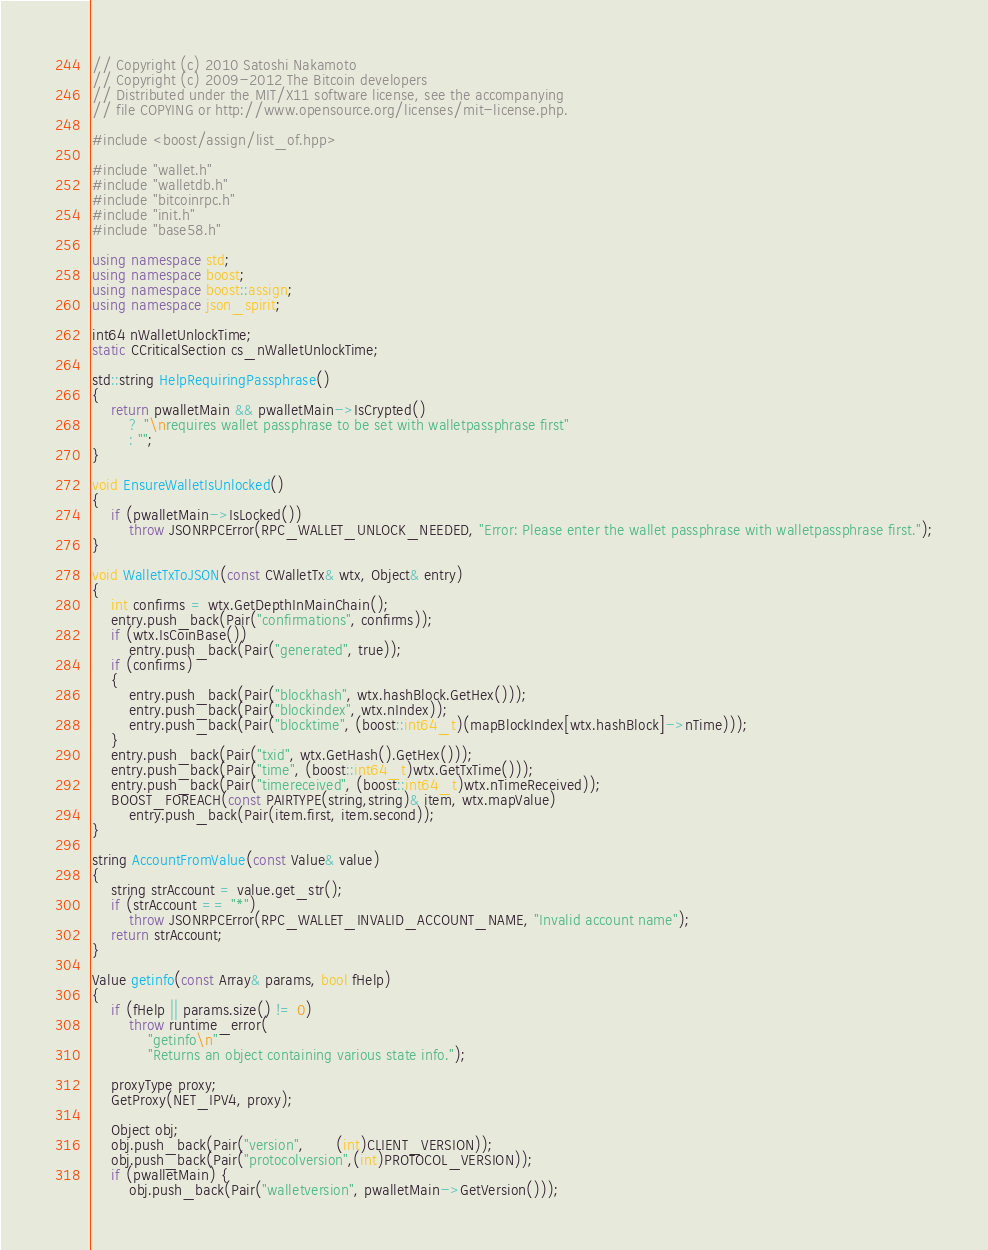Convert code to text. <code><loc_0><loc_0><loc_500><loc_500><_C++_>// Copyright (c) 2010 Satoshi Nakamoto
// Copyright (c) 2009-2012 The Bitcoin developers
// Distributed under the MIT/X11 software license, see the accompanying
// file COPYING or http://www.opensource.org/licenses/mit-license.php.

#include <boost/assign/list_of.hpp>

#include "wallet.h"
#include "walletdb.h"
#include "bitcoinrpc.h"
#include "init.h"
#include "base58.h"

using namespace std;
using namespace boost;
using namespace boost::assign;
using namespace json_spirit;

int64 nWalletUnlockTime;
static CCriticalSection cs_nWalletUnlockTime;

std::string HelpRequiringPassphrase()
{
    return pwalletMain && pwalletMain->IsCrypted()
        ? "\nrequires wallet passphrase to be set with walletpassphrase first"
        : "";
}

void EnsureWalletIsUnlocked()
{
    if (pwalletMain->IsLocked())
        throw JSONRPCError(RPC_WALLET_UNLOCK_NEEDED, "Error: Please enter the wallet passphrase with walletpassphrase first.");
}

void WalletTxToJSON(const CWalletTx& wtx, Object& entry)
{
    int confirms = wtx.GetDepthInMainChain();
    entry.push_back(Pair("confirmations", confirms));
    if (wtx.IsCoinBase())
        entry.push_back(Pair("generated", true));
    if (confirms)
    {
        entry.push_back(Pair("blockhash", wtx.hashBlock.GetHex()));
        entry.push_back(Pair("blockindex", wtx.nIndex));
        entry.push_back(Pair("blocktime", (boost::int64_t)(mapBlockIndex[wtx.hashBlock]->nTime)));
    }
    entry.push_back(Pair("txid", wtx.GetHash().GetHex()));
    entry.push_back(Pair("time", (boost::int64_t)wtx.GetTxTime()));
    entry.push_back(Pair("timereceived", (boost::int64_t)wtx.nTimeReceived));
    BOOST_FOREACH(const PAIRTYPE(string,string)& item, wtx.mapValue)
        entry.push_back(Pair(item.first, item.second));
}

string AccountFromValue(const Value& value)
{
    string strAccount = value.get_str();
    if (strAccount == "*")
        throw JSONRPCError(RPC_WALLET_INVALID_ACCOUNT_NAME, "Invalid account name");
    return strAccount;
}

Value getinfo(const Array& params, bool fHelp)
{
    if (fHelp || params.size() != 0)
        throw runtime_error(
            "getinfo\n"
            "Returns an object containing various state info.");

    proxyType proxy;
    GetProxy(NET_IPV4, proxy);

    Object obj;
    obj.push_back(Pair("version",       (int)CLIENT_VERSION));
    obj.push_back(Pair("protocolversion",(int)PROTOCOL_VERSION));
    if (pwalletMain) {
        obj.push_back(Pair("walletversion", pwalletMain->GetVersion()));</code> 